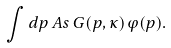Convert formula to latex. <formula><loc_0><loc_0><loc_500><loc_500>\int d p \, A s \, G ( p , \kappa ) \varphi ( p ) .</formula> 